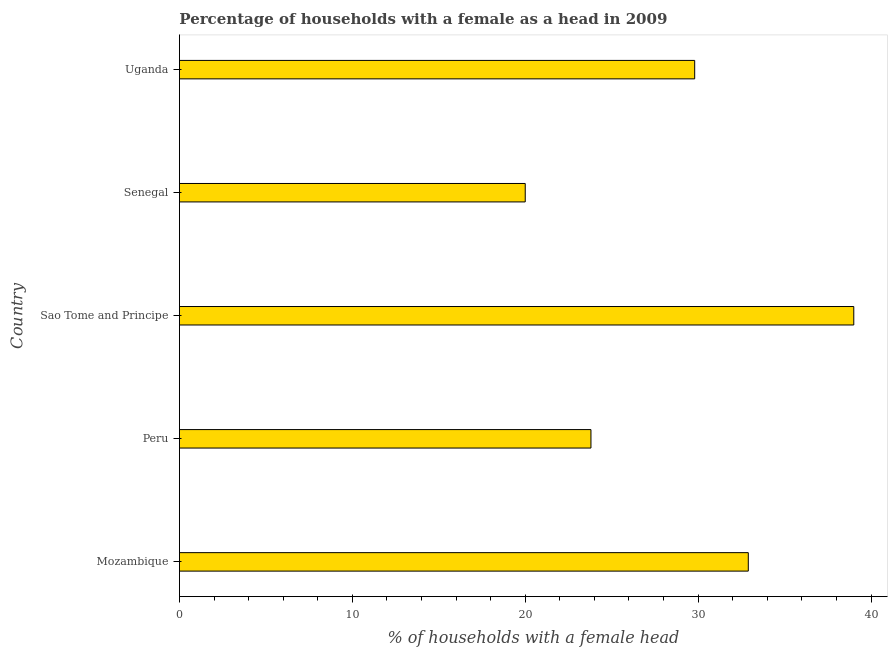Does the graph contain grids?
Your answer should be compact. No. What is the title of the graph?
Your answer should be very brief. Percentage of households with a female as a head in 2009. What is the label or title of the X-axis?
Ensure brevity in your answer.  % of households with a female head. Across all countries, what is the minimum number of female supervised households?
Give a very brief answer. 20. In which country was the number of female supervised households maximum?
Offer a very short reply. Sao Tome and Principe. In which country was the number of female supervised households minimum?
Ensure brevity in your answer.  Senegal. What is the sum of the number of female supervised households?
Provide a short and direct response. 145.5. What is the difference between the number of female supervised households in Mozambique and Sao Tome and Principe?
Ensure brevity in your answer.  -6.1. What is the average number of female supervised households per country?
Make the answer very short. 29.1. What is the median number of female supervised households?
Keep it short and to the point. 29.8. What is the ratio of the number of female supervised households in Senegal to that in Uganda?
Keep it short and to the point. 0.67. In how many countries, is the number of female supervised households greater than the average number of female supervised households taken over all countries?
Your answer should be very brief. 3. How many bars are there?
Your answer should be very brief. 5. Are all the bars in the graph horizontal?
Provide a succinct answer. Yes. How many countries are there in the graph?
Provide a short and direct response. 5. What is the difference between two consecutive major ticks on the X-axis?
Keep it short and to the point. 10. Are the values on the major ticks of X-axis written in scientific E-notation?
Your answer should be very brief. No. What is the % of households with a female head of Mozambique?
Keep it short and to the point. 32.9. What is the % of households with a female head in Peru?
Ensure brevity in your answer.  23.8. What is the % of households with a female head of Senegal?
Ensure brevity in your answer.  20. What is the % of households with a female head in Uganda?
Your response must be concise. 29.8. What is the difference between the % of households with a female head in Peru and Sao Tome and Principe?
Give a very brief answer. -15.2. What is the difference between the % of households with a female head in Peru and Uganda?
Offer a very short reply. -6. What is the difference between the % of households with a female head in Sao Tome and Principe and Senegal?
Ensure brevity in your answer.  19. What is the difference between the % of households with a female head in Senegal and Uganda?
Keep it short and to the point. -9.8. What is the ratio of the % of households with a female head in Mozambique to that in Peru?
Keep it short and to the point. 1.38. What is the ratio of the % of households with a female head in Mozambique to that in Sao Tome and Principe?
Offer a terse response. 0.84. What is the ratio of the % of households with a female head in Mozambique to that in Senegal?
Ensure brevity in your answer.  1.65. What is the ratio of the % of households with a female head in Mozambique to that in Uganda?
Give a very brief answer. 1.1. What is the ratio of the % of households with a female head in Peru to that in Sao Tome and Principe?
Provide a short and direct response. 0.61. What is the ratio of the % of households with a female head in Peru to that in Senegal?
Offer a terse response. 1.19. What is the ratio of the % of households with a female head in Peru to that in Uganda?
Give a very brief answer. 0.8. What is the ratio of the % of households with a female head in Sao Tome and Principe to that in Senegal?
Offer a very short reply. 1.95. What is the ratio of the % of households with a female head in Sao Tome and Principe to that in Uganda?
Offer a terse response. 1.31. What is the ratio of the % of households with a female head in Senegal to that in Uganda?
Provide a succinct answer. 0.67. 